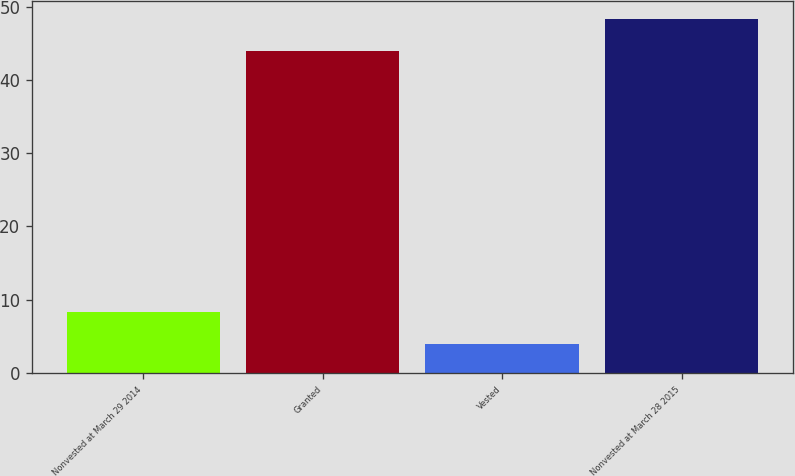Convert chart. <chart><loc_0><loc_0><loc_500><loc_500><bar_chart><fcel>Nonvested at March 29 2014<fcel>Granted<fcel>Vested<fcel>Nonvested at March 28 2015<nl><fcel>8.3<fcel>44<fcel>4<fcel>48.3<nl></chart> 